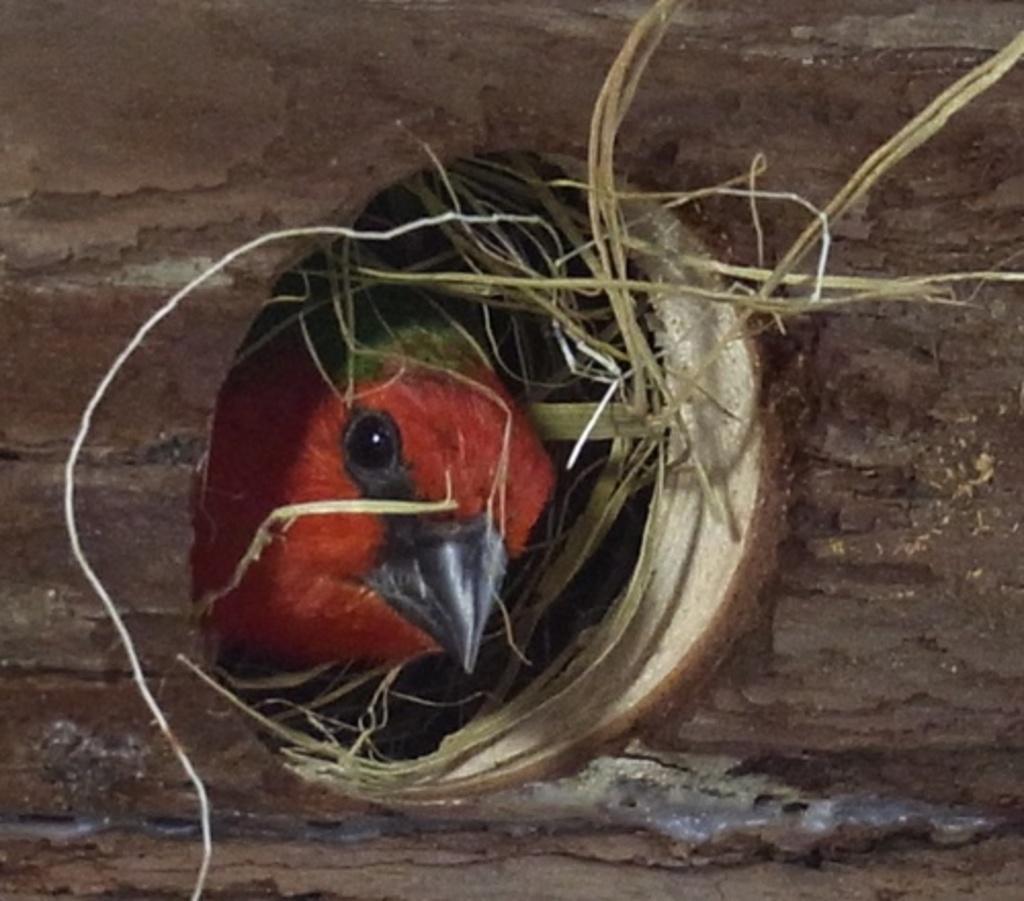Could you give a brief overview of what you see in this image? Here there is a red color bird in the nest. 